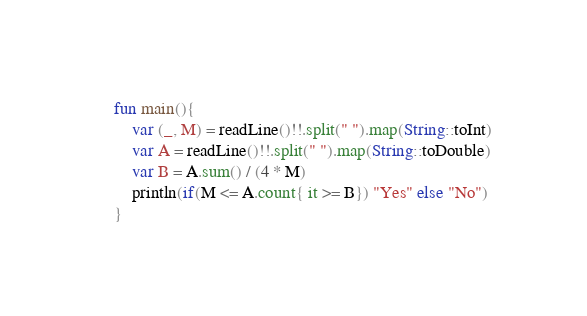<code> <loc_0><loc_0><loc_500><loc_500><_Kotlin_>fun main(){
    var (_, M) = readLine()!!.split(" ").map(String::toInt)
    var A = readLine()!!.split(" ").map(String::toDouble)
    var B = A.sum() / (4 * M)
    println(if(M <= A.count{ it >= B}) "Yes" else "No")
}</code> 